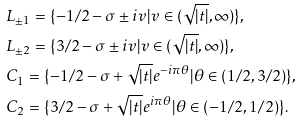Convert formula to latex. <formula><loc_0><loc_0><loc_500><loc_500>& L _ { \pm 1 } = \{ - 1 / 2 - \sigma \pm i v | v \in ( \sqrt { | t | } , \infty ) \} , \\ & L _ { \pm 2 } = \{ 3 / 2 - \sigma \pm i v | v \in ( \sqrt { | t | } , \infty ) \} , \\ & C _ { 1 } = \{ - 1 / 2 - \sigma + \sqrt { | t | } e ^ { - i \pi \theta } | \theta \in ( 1 / 2 , 3 / 2 ) \} , \\ & C _ { 2 } = \{ 3 / 2 - \sigma + \sqrt { | t | } e ^ { i \pi \theta } | \theta \in ( - 1 / 2 , 1 / 2 ) \} .</formula> 